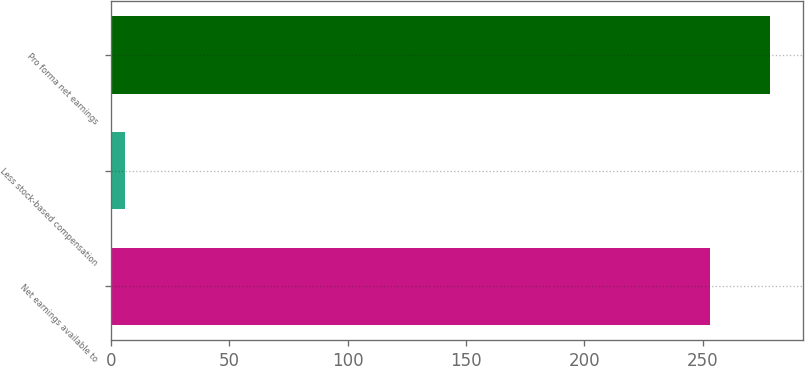Convert chart to OTSL. <chart><loc_0><loc_0><loc_500><loc_500><bar_chart><fcel>Net earnings available to<fcel>Less stock-based compensation<fcel>Pro forma net earnings<nl><fcel>253<fcel>6<fcel>278.3<nl></chart> 